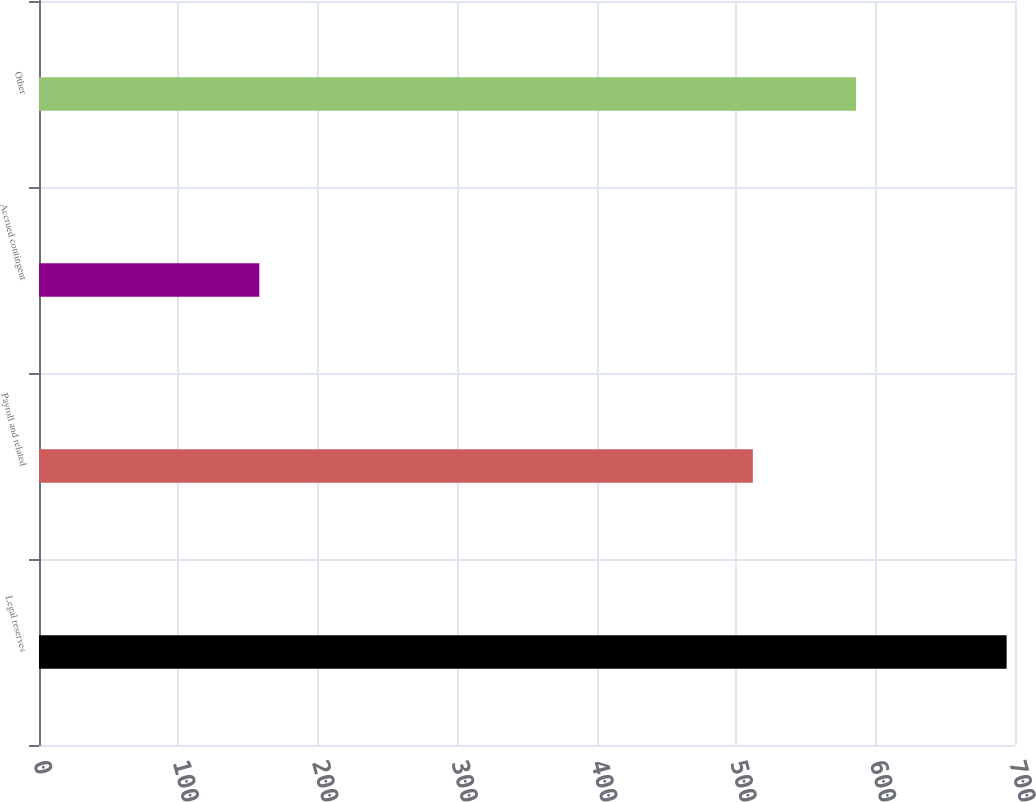<chart> <loc_0><loc_0><loc_500><loc_500><bar_chart><fcel>Legal reserves<fcel>Payroll and related<fcel>Accrued contingent<fcel>Other<nl><fcel>694<fcel>512<fcel>158<fcel>586<nl></chart> 